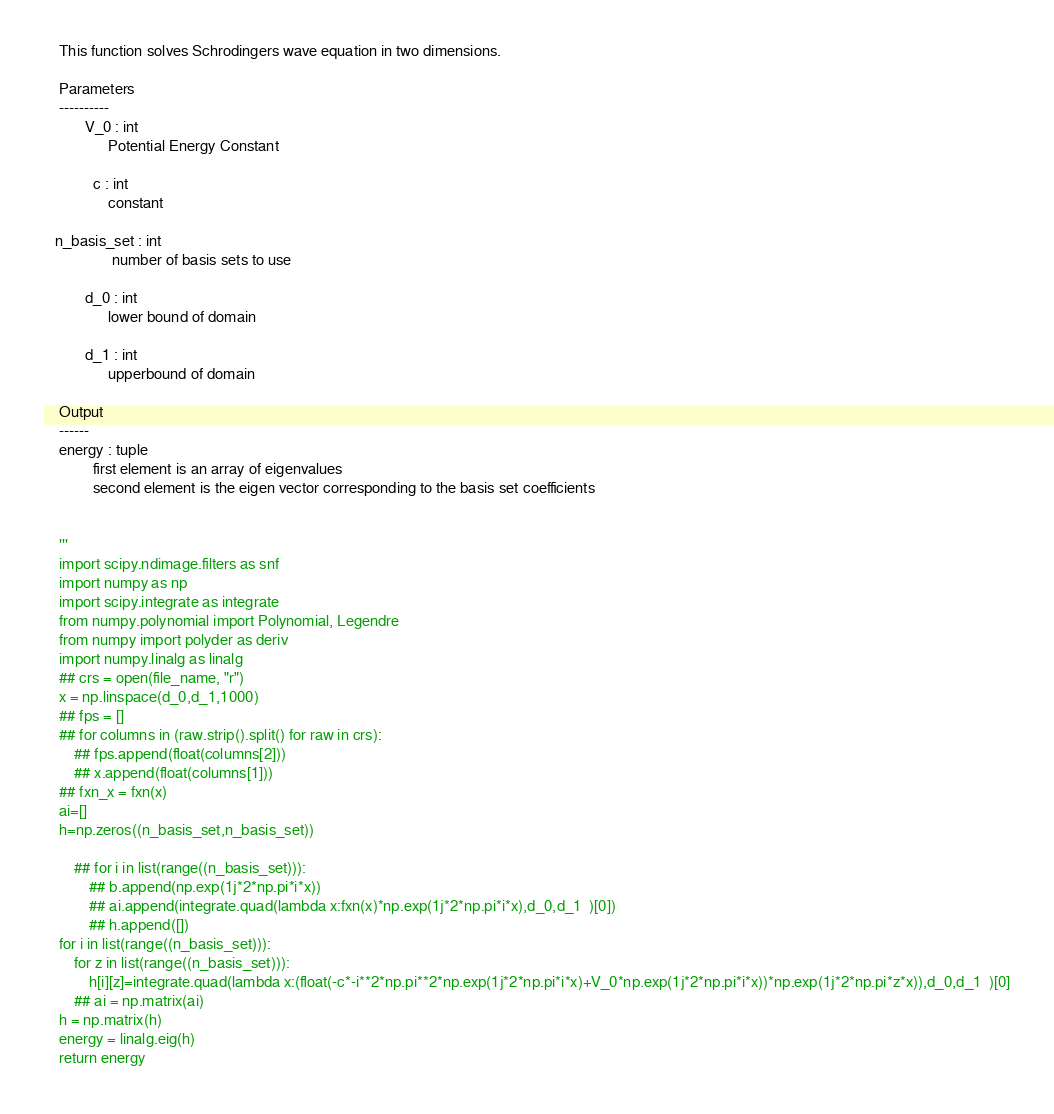Convert code to text. <code><loc_0><loc_0><loc_500><loc_500><_Python_>    This function solves Schrodingers wave equation in two dimensions.
    
    Parameters
    ----------
           V_0 : int
                 Potential Energy Constant
          
             c : int
                 constant
          
   n_basis_set : int
                  number of basis sets to use
    
           d_0 : int
                 lower bound of domain
        
           d_1 : int
                 upperbound of domain
                 
    Output
    ------
    energy : tuple
             first element is an array of eigenvalues
             second element is the eigen vector corresponding to the basis set coefficients
    
    
    '''
    import scipy.ndimage.filters as snf
    import numpy as np
    import scipy.integrate as integrate
    from numpy.polynomial import Polynomial, Legendre
    from numpy import polyder as deriv
    import numpy.linalg as linalg
    ## crs = open(file_name, "r")
    x = np.linspace(d_0,d_1,1000)
    ## fps = []
    ## for columns in (raw.strip().split() for raw in crs):
        ## fps.append(float(columns[2]))
        ## x.append(float(columns[1]))
    ## fxn_x = fxn(x)
    ai=[]
    h=np.zeros((n_basis_set,n_basis_set))

        ## for i in list(range((n_basis_set))):
            ## b.append(np.exp(1j*2*np.pi*i*x))
            ## ai.append(integrate.quad(lambda x:fxn(x)*np.exp(1j*2*np.pi*i*x),d_0,d_1  )[0])
            ## h.append([])
    for i in list(range((n_basis_set))):
        for z in list(range((n_basis_set))):
            h[i][z]=integrate.quad(lambda x:(float(-c*-i**2*np.pi**2*np.exp(1j*2*np.pi*i*x)+V_0*np.exp(1j*2*np.pi*i*x))*np.exp(1j*2*np.pi*z*x)),d_0,d_1  )[0]
        ## ai = np.matrix(ai)
    h = np.matrix(h)
    energy = linalg.eig(h)
    return energy
</code> 